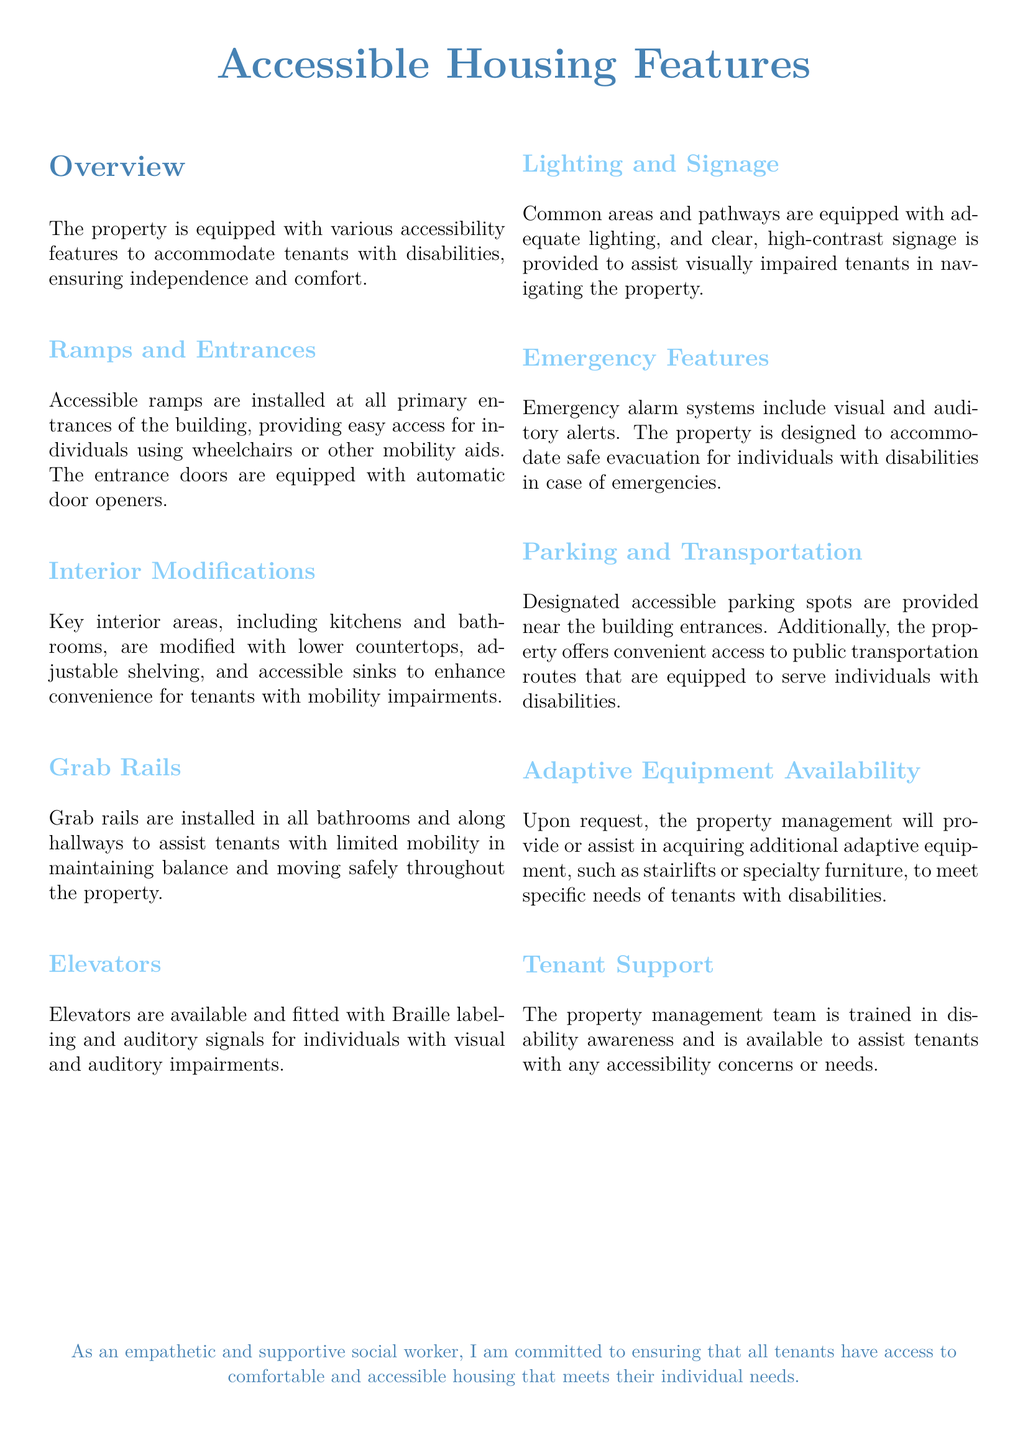What features accommodate mobility impairments? The document lists interior modifications like lower countertops and accessible sinks that enhance convenience for tenants with mobility impairments.
Answer: Lower countertops, accessible sinks How are the bathrooms adapted? The document states that grab rails are installed in all bathrooms to assist tenants with limited mobility in maintaining balance.
Answer: Grab rails What type of elevators are available? The document specifies that elevators are fitted with Braille labeling and auditory signals for individuals with visual and auditory impairments.
Answer: Braille labeling, auditory signals How does the property ensure emergency safety? The document explains that emergency alarm systems include visual and auditory alerts to assist individuals with disabilities during emergencies.
Answer: Visual and auditory alerts What support does property management provide? The document mentions that the management team is trained in disability awareness and available to assist tenants with accessibility concerns.
Answer: Trained in disability awareness Are ramps available for building access? The document confirms that accessible ramps are installed at all primary entrances of the building for easy access.
Answer: Accessible ramps How does the property accommodate parking needs? The document states that designated accessible parking spots are provided near the building entrances to meet the needs of tenants.
Answer: Designated accessible parking spots What is available upon request for tenants? The document indicates that property management will provide or assist in acquiring additional adaptive equipment upon request.
Answer: Additional adaptive equipment 